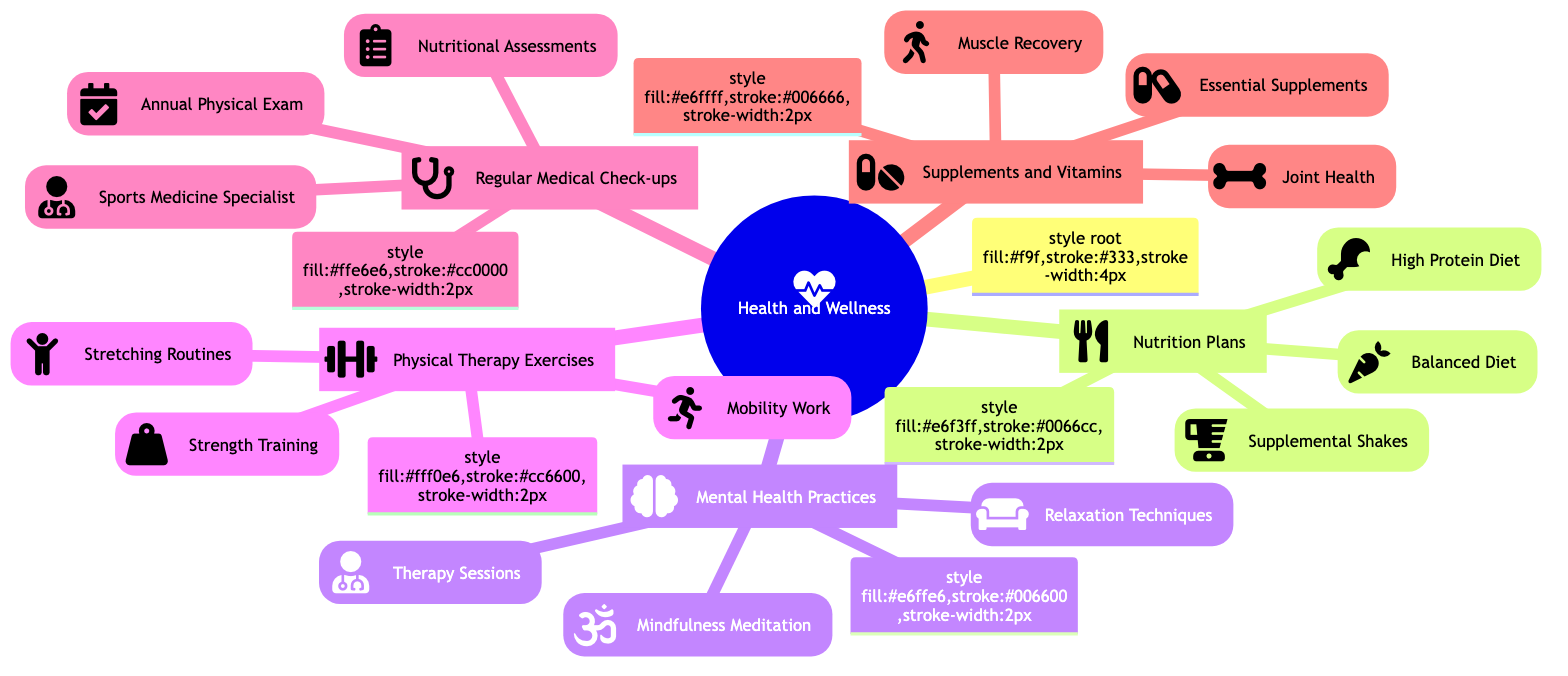What are the three types of Nutrition Plans listed? The diagram indicates that there are three nodes under Nutrition Plans: High Protein Diet, Balanced Diet, and Supplemental Shakes.
Answer: High Protein Diet, Balanced Diet, Supplemental Shakes How many Mental Health Practices are there? The diagram shows three distinct practices under Mental Health Practices: Mindfulness Meditation, Therapy Sessions, and Relaxation Techniques. Hence, their count is three.
Answer: 3 Which section includes Strength Training? Looking at the categories, Strength Training is categorized under Physical Therapy Exercises along with other exercise types.
Answer: Physical Therapy Exercises What is one type of Essential Supplement mentioned? The diagram lists Essential Supplements, which includes Omega-3 fatty acids as one of the components.
Answer: Omega-3 fatty acids How does Regular Medical Check-ups relate to Nutrition Plans? Regular Medical Check-ups and Nutrition Plans are both main branches under the Health and Wellness section, indicating that they are equal categories rather than directly related.
Answer: No direct relationship Name a Relaxation Technique listed in the diagram. Under Mental Health Practices, one of the relaxation techniques mentioned is Progressive muscle relaxation.
Answer: Progressive muscle relaxation What is the primary focus of the Physical Therapy Exercises section? Physical Therapy Exercises centers around rehabilitation practices focusing on body movement and recovery, indicated by three subcategories: Stretching Routines, Strength Training, and Mobility Work.
Answer: Rehabilitation practices How many types of Joint Health supplements are listed? The diagram shows that there are two types listed under Joint Health: Glucosamine and Chondroitin sulfate.
Answer: 2 Which app is associated with Mindfulness Meditation? The diagram provides two specific app options for Mindfulness Meditation: Headspace app and Calm app; thus naming either suffices.
Answer: Headspace app or Calm app 